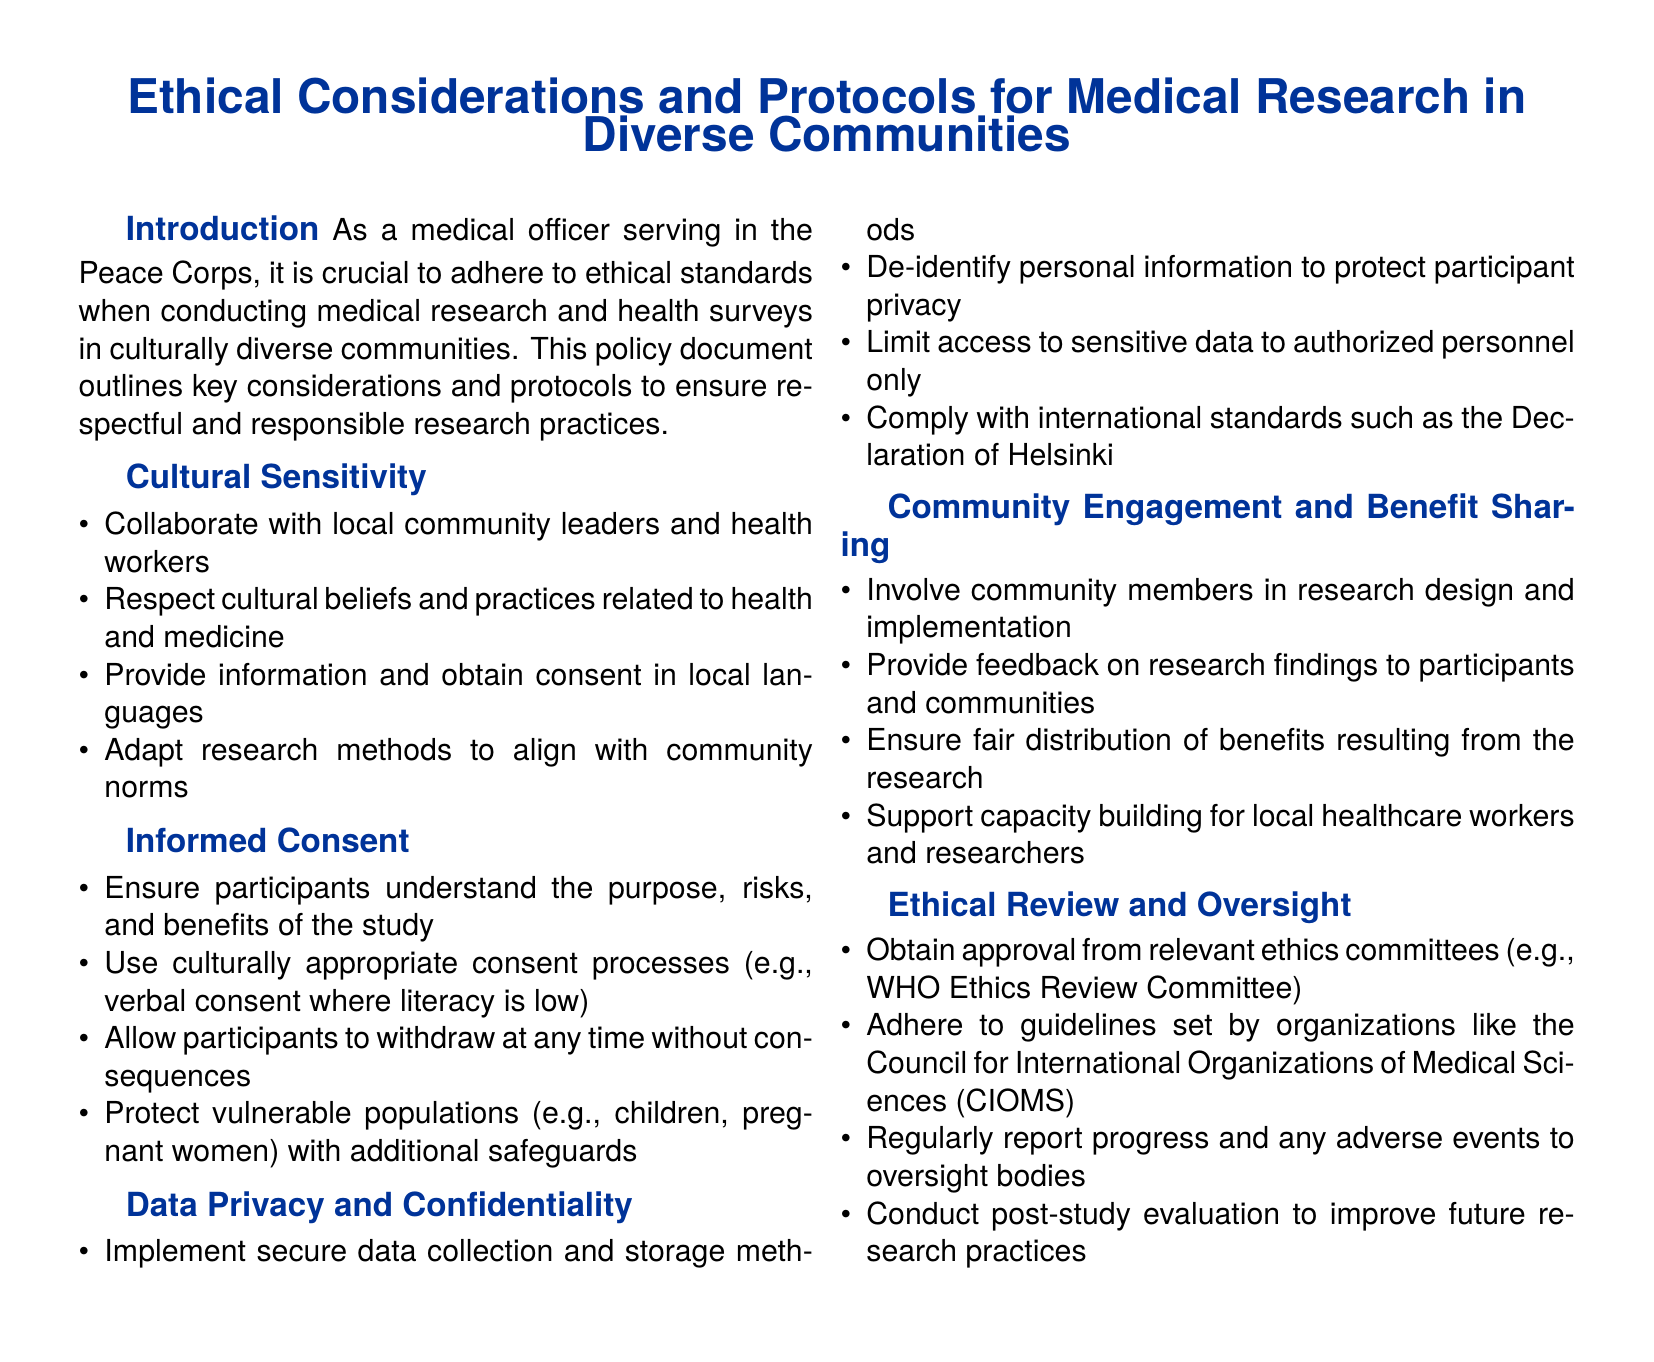What is the document about? The document outlines ethical considerations and protocols for conducting medical research and health surveys in culturally diverse communities.
Answer: Ethical considerations and protocols for medical research in diverse communities What should be respected in culturally diverse communities? The document states that it is important to respect cultural beliefs and practices related to health and medicine.
Answer: Cultural beliefs and practices What type of consent should be used where literacy is low? The document mentions using verbal consent where literacy is low.
Answer: Verbal consent What is required to protect participant privacy? The document specifies implementing secure data collection and storage methods and de-identifying personal information.
Answer: De-identifying personal information Who needs to approve research protocols? The document states that approval from relevant ethics committees is necessary.
Answer: Ethics committees What does the document encourage regarding community engagement? It encourages involving community members in research design and implementation.
Answer: Involving community members What should participants be allowed to do at any time? Participants should be allowed to withdraw at any time without consequences.
Answer: Withdraw What type of evaluation is mentioned for improving future practices? The document mentions conducting post-study evaluation.
Answer: Post-study evaluation Which organization is mentioned as a guideline for ethical review? The Council for International Organizations of Medical Sciences (CIOMS) is mentioned.
Answer: CIOMS 